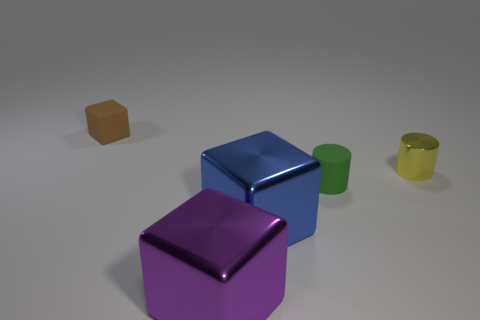Is the shape of the matte object on the right side of the purple shiny cube the same as the small rubber object that is on the left side of the small green matte cylinder?
Offer a terse response. No. Are any tiny red rubber objects visible?
Your response must be concise. No. What is the material of the other tiny thing that is the same shape as the yellow thing?
Your response must be concise. Rubber. Are there any matte cylinders in front of the big purple metallic thing?
Give a very brief answer. No. Does the tiny brown block that is behind the tiny matte cylinder have the same material as the yellow cylinder?
Provide a short and direct response. No. Is there a object that has the same color as the small rubber block?
Your response must be concise. No. The brown rubber object has what shape?
Ensure brevity in your answer.  Cube. The large cube that is on the right side of the big block in front of the blue shiny block is what color?
Provide a short and direct response. Blue. How big is the rubber thing left of the tiny green rubber object?
Your answer should be very brief. Small. Are there any blue cylinders made of the same material as the green thing?
Your answer should be compact. No. 